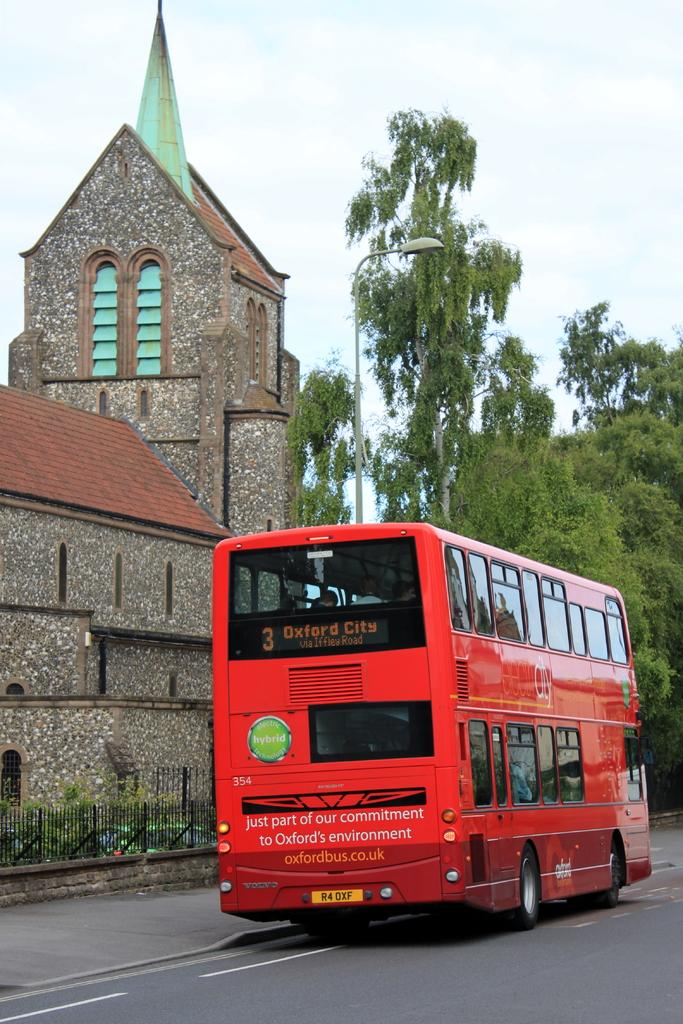What type of vehicle is on the road in the image? There is a bus on the road in the image. What can be seen near the road in the image? There is a fence in the image. What type of natural elements are present in the image? There are plants, trees, and the sky visible in the image. What type of man-made structure is present in the image? There is a building in the image. What is the purpose of the light pole in the image? The light pole in the image provides illumination. Can you see any jellyfish swimming in the sky in the image? No, there are no jellyfish present in the image. Is there a kitty playing with the building in the image? No, there is no kitty present in the image. 